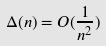<formula> <loc_0><loc_0><loc_500><loc_500>\Delta ( n ) = O ( \frac { 1 } { n ^ { 2 } } )</formula> 